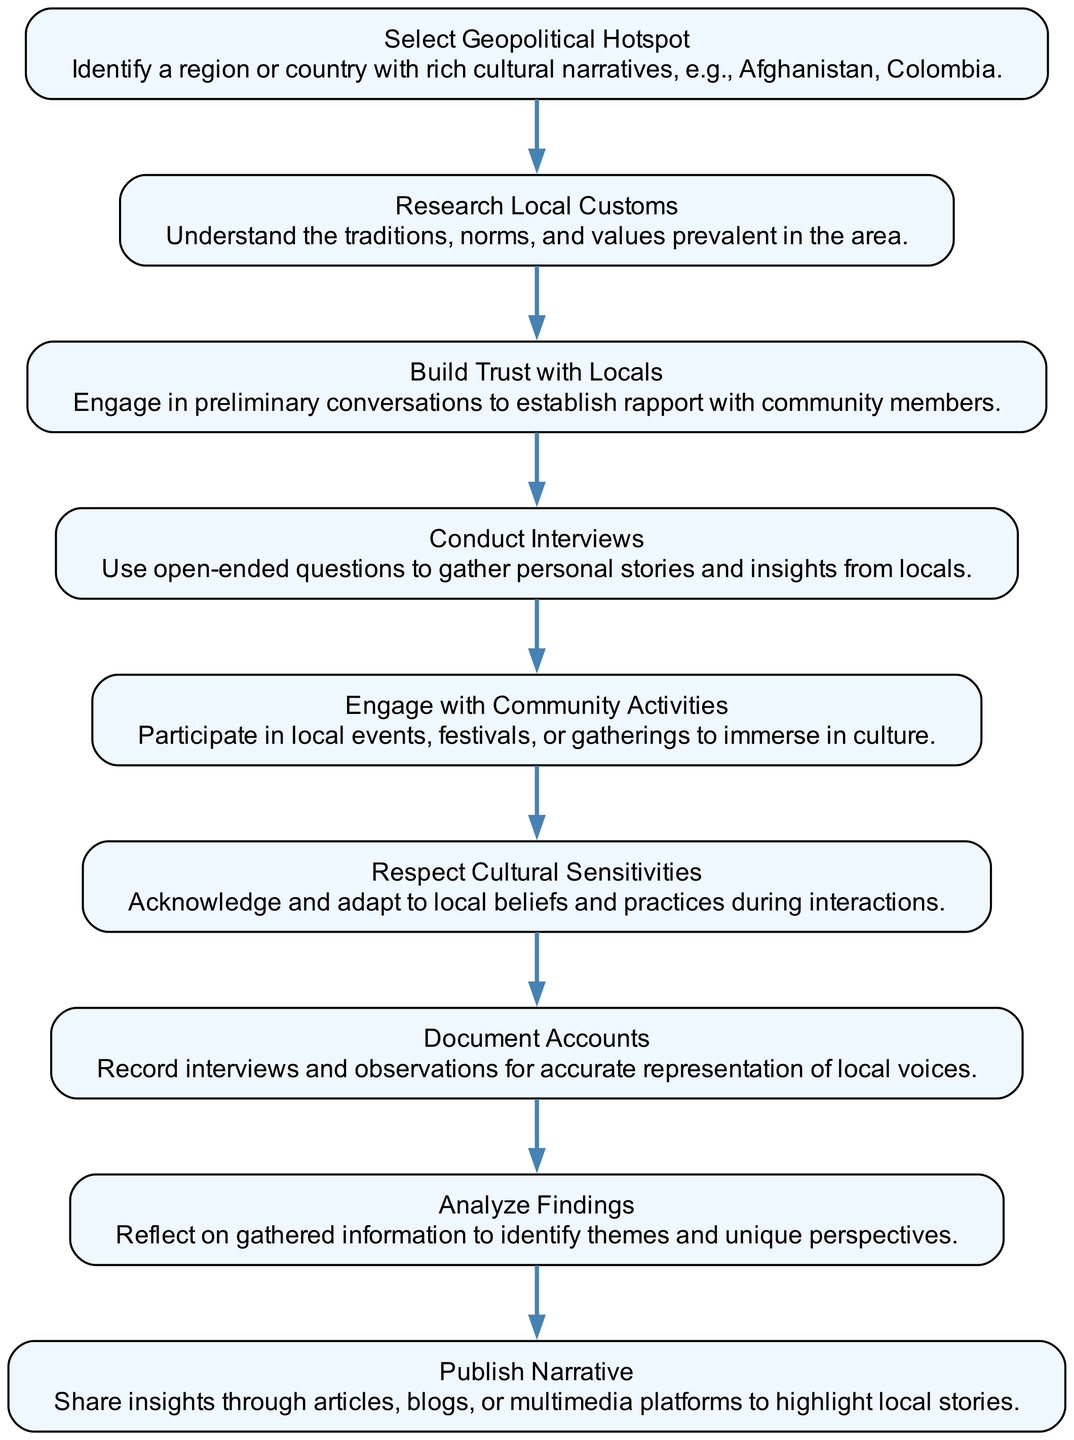What is the first step in the flow chart? The first step is "Select Geopolitical Hotspot," which is at the top of the flow chart and represents the starting point for gathering cultural narratives.
Answer: Select Geopolitical Hotspot How many nodes are present in the diagram? There are nine nodes in the diagram, each representing a different stage of the reporting process.
Answer: Nine What action follows "Build Trust with Locals"? The action that follows "Build Trust with Locals" is "Conduct Interviews," indicating the progress in the flow of gathering firsthand accounts.
Answer: Conduct Interviews What is the last step in the flow chart? The last step is "Publish Narrative," which wraps up the entire flow by sharing the gathered insights.
Answer: Publish Narrative What is the significance of "Respect Cultural Sensitivities"? "Respect Cultural Sensitivities" emphasizes the importance of adapting to local beliefs during interactions, essential for ethical engagement with the community.
Answer: Acknowledge and adapt What two steps are connected directly after "Research Local Customs"? The two steps directly connected after "Research Local Customs" are "Build Trust with Locals" and "Respect Cultural Sensitivities," which are crucial for successful engagement in the field.
Answer: Build Trust with Locals, Respect Cultural Sensitivities Identify the relationship between "Engage with Community Activities" and "Document Accounts." "Engage with Community Activities" contributes to "Document Accounts," as participating in local events helps gather firsthand observations to represent local voices accurately.
Answer: Contributes How does "Analyze Findings" relate to "Conduct Interviews"? "Analyze Findings" follows "Document Accounts" but builds upon the insights gathered from "Conduct Interviews," forming a crucial part of the overall narrative-building process.
Answer: Builds upon What is the primary focus of the flow chart? The primary focus is on the process of gathering firsthand accounts and sharing local cultures through a series of defined steps.
Answer: Gathering firsthand accounts 